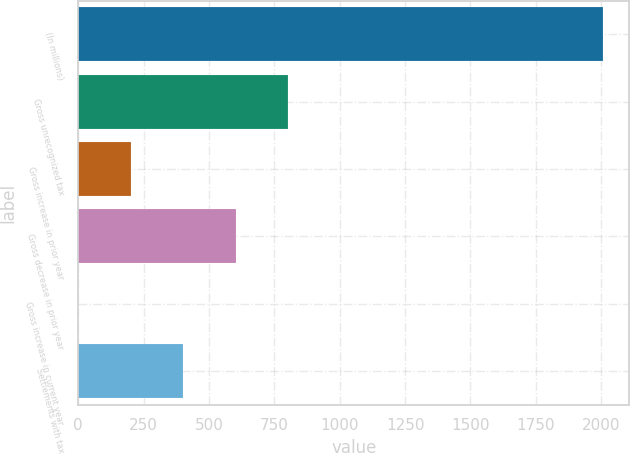Convert chart to OTSL. <chart><loc_0><loc_0><loc_500><loc_500><bar_chart><fcel>(In millions)<fcel>Gross unrecognized tax<fcel>Gross increase in prior year<fcel>Gross decrease in prior year<fcel>Gross increase in current year<fcel>Settlements with tax<nl><fcel>2007<fcel>803.4<fcel>201.6<fcel>602.8<fcel>1<fcel>402.2<nl></chart> 